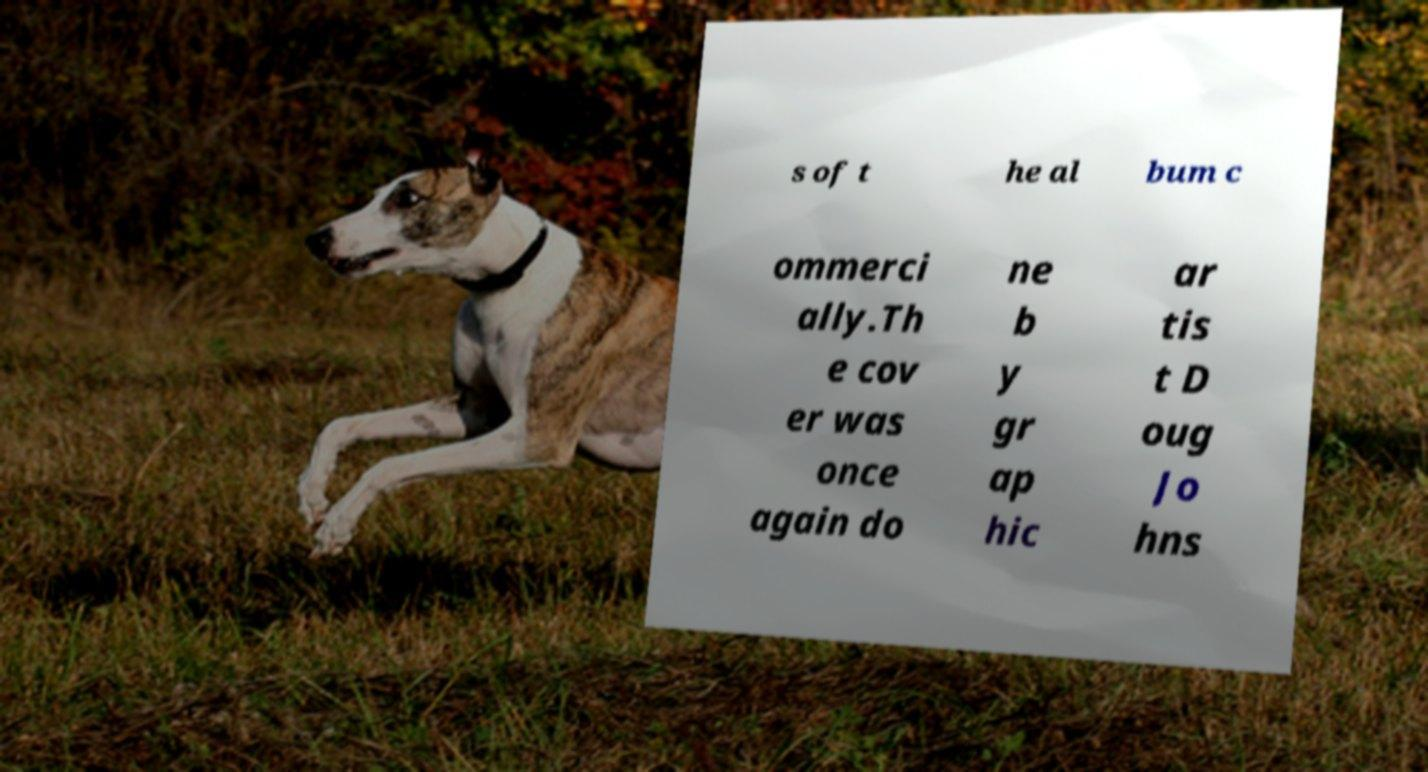I need the written content from this picture converted into text. Can you do that? s of t he al bum c ommerci ally.Th e cov er was once again do ne b y gr ap hic ar tis t D oug Jo hns 